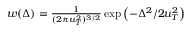<formula> <loc_0><loc_0><loc_500><loc_500>\begin{array} { r } { w ( \Delta ) = { \frac { 1 } { ( 2 \pi u _ { T } ^ { 2 } ) ^ { 3 / 2 } } } \exp \left ( - { \Delta ^ { 2 } / 2 u _ { T } ^ { 2 } } \right ) } \end{array}</formula> 